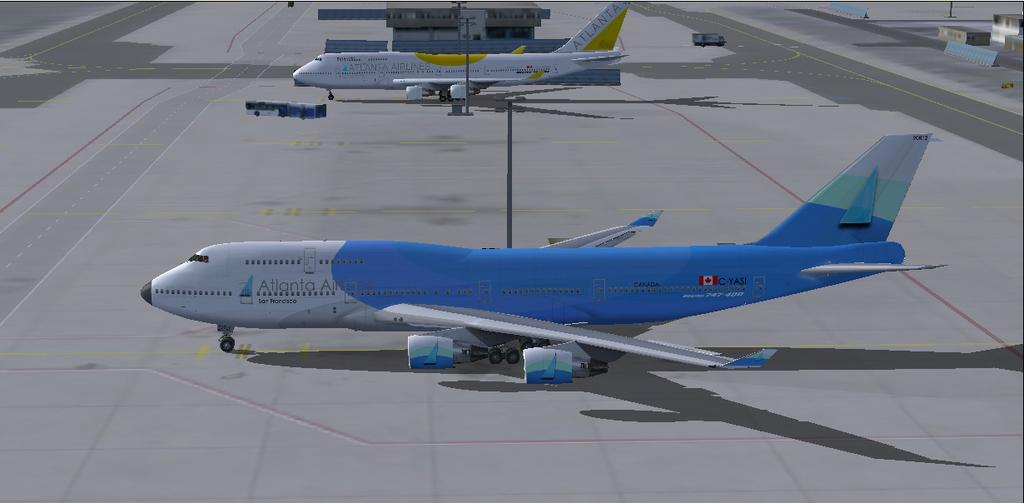What types of vehicles are present in the image? There are airplanes and buses in the image. What structures are associated with the airplanes in the image? There are runways in the image. What type of buildings can be seen in the image? There are houses in the image. Can you describe any other objects present in the image? There are a few other objects in the image. What type of powder is being used to make pizzas in the image? There is no mention of pizzas or powder in the image; it features airplanes, buses, runways, and houses. 